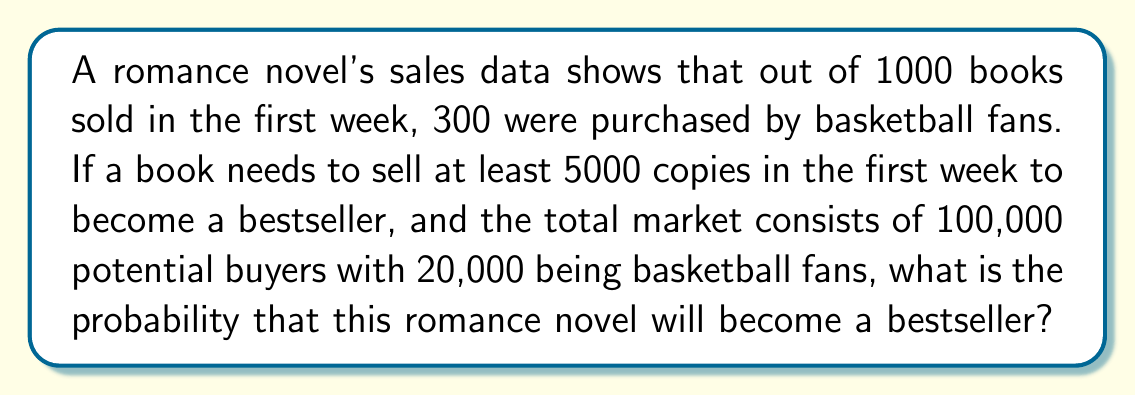Provide a solution to this math problem. Let's approach this step-by-step:

1) First, we need to calculate the probability of a person buying the book in the first week:
   $P(\text{buy}) = \frac{\text{Books sold}}{\text{Total potential buyers}} = \frac{1000}{100000} = 0.01$

2) Now, let's calculate the probability of a basketball fan buying the book:
   $P(\text{buy|fan}) = \frac{\text{Books sold to fans}}{\text{Total fans}} = \frac{300}{20000} = 0.015$

3) And the probability of a non-fan buying the book:
   $P(\text{buy|not fan}) = \frac{\text{Books sold to non-fans}}{\text{Total non-fans}} = \frac{700}{80000} = 0.00875$

4) To become a bestseller, the book needs to sell at least 5000 copies. This follows a binomial distribution with $n = 100000$ and $p = 0.01$.

5) We can use the normal approximation to the binomial distribution since $np$ and $n(1-p)$ are both greater than 5.

6) The mean of this distribution is:
   $\mu = np = 100000 \cdot 0.01 = 1000$

7) The standard deviation is:
   $\sigma = \sqrt{np(1-p)} = \sqrt{100000 \cdot 0.01 \cdot 0.99} = \sqrt{990} \approx 31.46$

8) We want to find $P(X \geq 5000)$. First, we calculate the z-score:
   $z = \frac{5000 - 1000}{31.46} \approx 127.15$

9) The probability of $Z \geq 127.15$ is essentially 0 (it's so far out in the tail of the distribution).

Therefore, based on the current sales data, the probability of this romance novel becoming a bestseller is practically zero.
Answer: $\approx 0$ 